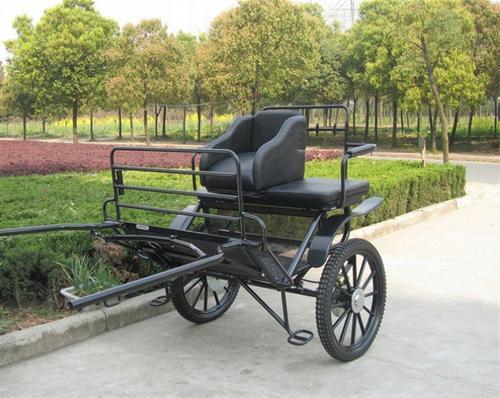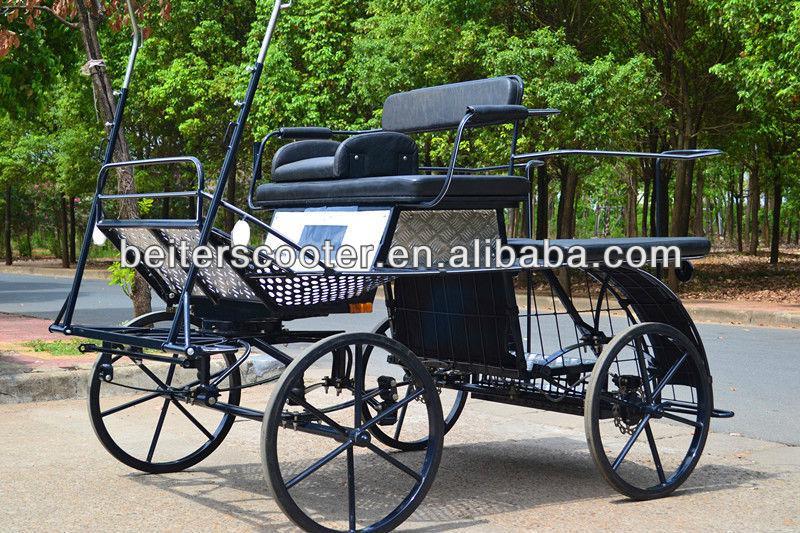The first image is the image on the left, the second image is the image on the right. Given the left and right images, does the statement "The carriage is covered in the image on the right." hold true? Answer yes or no. No. 